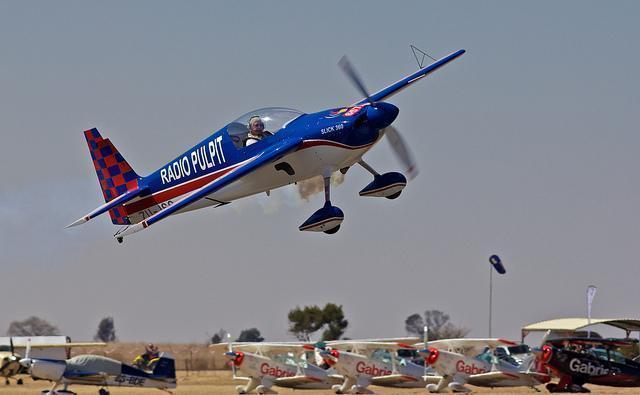What is the man doing in the front of the blue plane?
From the following set of four choices, select the accurate answer to respond to the question.
Options: Selling it, repairing it, flying it, washing it. Flying it. 